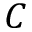Convert formula to latex. <formula><loc_0><loc_0><loc_500><loc_500>C</formula> 